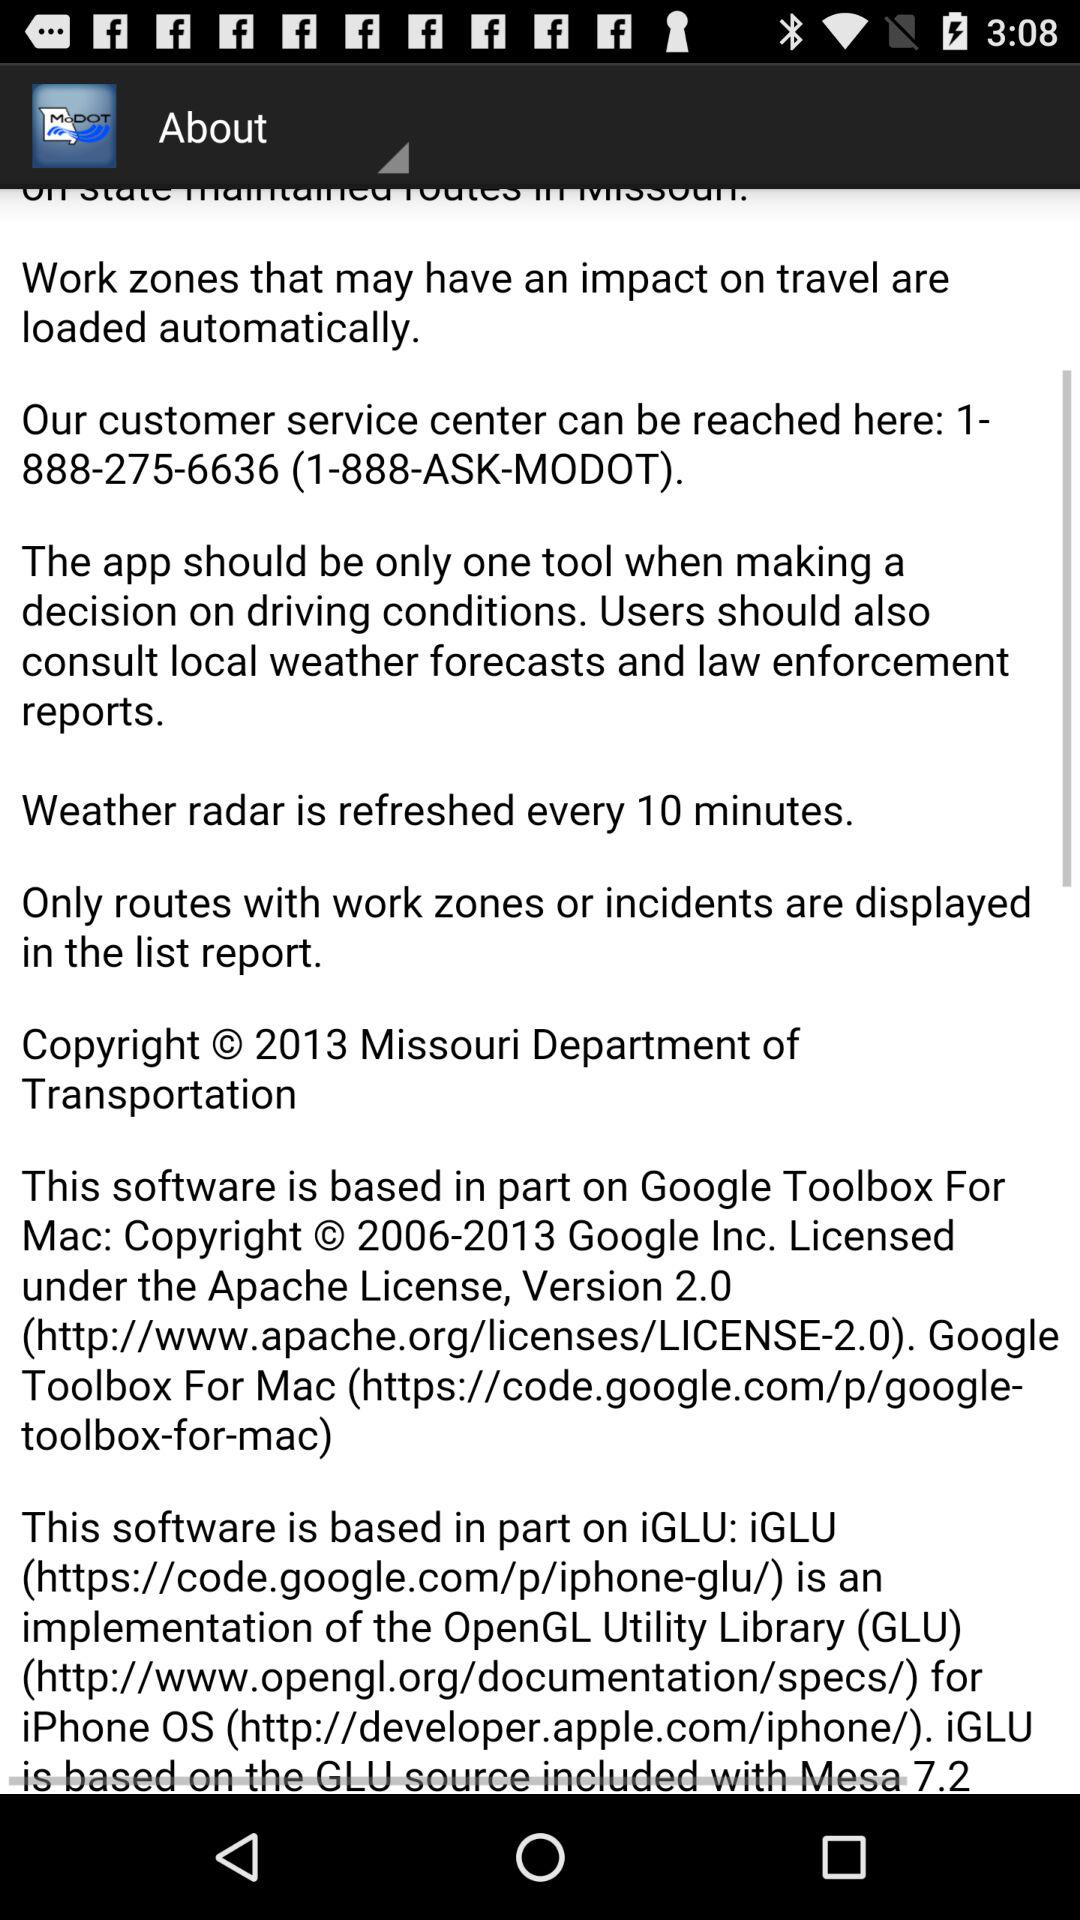What is the copyright year of the Missouri Department of Transportation? The copyright year is 2013. 